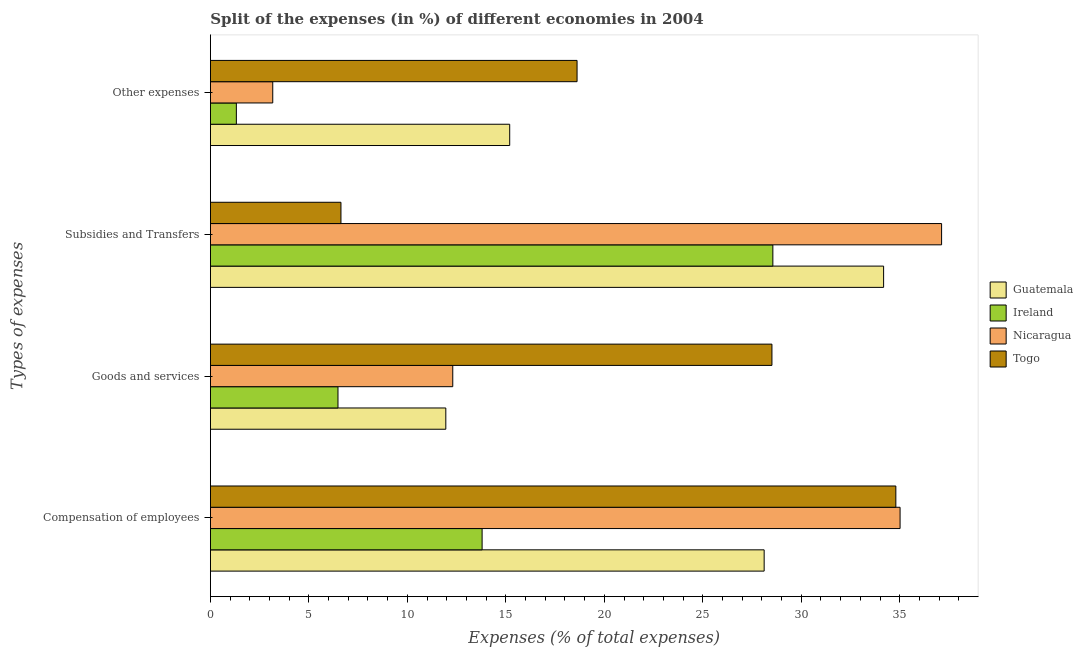How many groups of bars are there?
Provide a succinct answer. 4. How many bars are there on the 2nd tick from the top?
Offer a very short reply. 4. How many bars are there on the 2nd tick from the bottom?
Offer a very short reply. 4. What is the label of the 3rd group of bars from the top?
Offer a very short reply. Goods and services. What is the percentage of amount spent on compensation of employees in Ireland?
Give a very brief answer. 13.8. Across all countries, what is the maximum percentage of amount spent on goods and services?
Provide a short and direct response. 28.51. Across all countries, what is the minimum percentage of amount spent on compensation of employees?
Your response must be concise. 13.8. In which country was the percentage of amount spent on compensation of employees maximum?
Give a very brief answer. Nicaragua. In which country was the percentage of amount spent on goods and services minimum?
Ensure brevity in your answer.  Ireland. What is the total percentage of amount spent on subsidies in the graph?
Offer a very short reply. 106.49. What is the difference between the percentage of amount spent on compensation of employees in Togo and that in Nicaragua?
Your response must be concise. -0.22. What is the difference between the percentage of amount spent on compensation of employees in Nicaragua and the percentage of amount spent on other expenses in Ireland?
Keep it short and to the point. 33.7. What is the average percentage of amount spent on other expenses per country?
Your answer should be very brief. 9.57. What is the difference between the percentage of amount spent on goods and services and percentage of amount spent on other expenses in Guatemala?
Your answer should be very brief. -3.24. What is the ratio of the percentage of amount spent on compensation of employees in Nicaragua to that in Guatemala?
Give a very brief answer. 1.25. What is the difference between the highest and the second highest percentage of amount spent on other expenses?
Your answer should be very brief. 3.42. What is the difference between the highest and the lowest percentage of amount spent on other expenses?
Give a very brief answer. 17.3. In how many countries, is the percentage of amount spent on subsidies greater than the average percentage of amount spent on subsidies taken over all countries?
Provide a short and direct response. 3. Is the sum of the percentage of amount spent on goods and services in Guatemala and Nicaragua greater than the maximum percentage of amount spent on subsidies across all countries?
Ensure brevity in your answer.  No. What does the 2nd bar from the top in Compensation of employees represents?
Provide a short and direct response. Nicaragua. What does the 2nd bar from the bottom in Other expenses represents?
Offer a very short reply. Ireland. How many bars are there?
Your response must be concise. 16. How many countries are there in the graph?
Your answer should be compact. 4. What is the difference between two consecutive major ticks on the X-axis?
Offer a very short reply. 5. Are the values on the major ticks of X-axis written in scientific E-notation?
Offer a very short reply. No. Does the graph contain any zero values?
Provide a short and direct response. No. Does the graph contain grids?
Your response must be concise. No. How are the legend labels stacked?
Make the answer very short. Vertical. What is the title of the graph?
Your response must be concise. Split of the expenses (in %) of different economies in 2004. What is the label or title of the X-axis?
Make the answer very short. Expenses (% of total expenses). What is the label or title of the Y-axis?
Give a very brief answer. Types of expenses. What is the Expenses (% of total expenses) in Guatemala in Compensation of employees?
Keep it short and to the point. 28.12. What is the Expenses (% of total expenses) in Ireland in Compensation of employees?
Offer a terse response. 13.8. What is the Expenses (% of total expenses) in Nicaragua in Compensation of employees?
Your response must be concise. 35.02. What is the Expenses (% of total expenses) of Togo in Compensation of employees?
Keep it short and to the point. 34.8. What is the Expenses (% of total expenses) of Guatemala in Goods and services?
Your answer should be very brief. 11.95. What is the Expenses (% of total expenses) of Ireland in Goods and services?
Your answer should be compact. 6.48. What is the Expenses (% of total expenses) of Nicaragua in Goods and services?
Keep it short and to the point. 12.31. What is the Expenses (% of total expenses) of Togo in Goods and services?
Give a very brief answer. 28.51. What is the Expenses (% of total expenses) of Guatemala in Subsidies and Transfers?
Give a very brief answer. 34.18. What is the Expenses (% of total expenses) of Ireland in Subsidies and Transfers?
Your response must be concise. 28.56. What is the Expenses (% of total expenses) in Nicaragua in Subsidies and Transfers?
Ensure brevity in your answer.  37.12. What is the Expenses (% of total expenses) of Togo in Subsidies and Transfers?
Make the answer very short. 6.63. What is the Expenses (% of total expenses) of Guatemala in Other expenses?
Ensure brevity in your answer.  15.2. What is the Expenses (% of total expenses) in Ireland in Other expenses?
Provide a short and direct response. 1.32. What is the Expenses (% of total expenses) of Nicaragua in Other expenses?
Make the answer very short. 3.17. What is the Expenses (% of total expenses) in Togo in Other expenses?
Give a very brief answer. 18.62. Across all Types of expenses, what is the maximum Expenses (% of total expenses) of Guatemala?
Give a very brief answer. 34.18. Across all Types of expenses, what is the maximum Expenses (% of total expenses) in Ireland?
Your answer should be compact. 28.56. Across all Types of expenses, what is the maximum Expenses (% of total expenses) in Nicaragua?
Provide a succinct answer. 37.12. Across all Types of expenses, what is the maximum Expenses (% of total expenses) of Togo?
Give a very brief answer. 34.8. Across all Types of expenses, what is the minimum Expenses (% of total expenses) in Guatemala?
Make the answer very short. 11.95. Across all Types of expenses, what is the minimum Expenses (% of total expenses) of Ireland?
Offer a terse response. 1.32. Across all Types of expenses, what is the minimum Expenses (% of total expenses) of Nicaragua?
Provide a short and direct response. 3.17. Across all Types of expenses, what is the minimum Expenses (% of total expenses) in Togo?
Your answer should be compact. 6.63. What is the total Expenses (% of total expenses) in Guatemala in the graph?
Your answer should be compact. 89.44. What is the total Expenses (% of total expenses) in Ireland in the graph?
Offer a terse response. 50.15. What is the total Expenses (% of total expenses) in Nicaragua in the graph?
Offer a very short reply. 87.61. What is the total Expenses (% of total expenses) of Togo in the graph?
Ensure brevity in your answer.  88.56. What is the difference between the Expenses (% of total expenses) of Guatemala in Compensation of employees and that in Goods and services?
Your answer should be very brief. 16.16. What is the difference between the Expenses (% of total expenses) in Ireland in Compensation of employees and that in Goods and services?
Your answer should be very brief. 7.32. What is the difference between the Expenses (% of total expenses) of Nicaragua in Compensation of employees and that in Goods and services?
Keep it short and to the point. 22.71. What is the difference between the Expenses (% of total expenses) of Togo in Compensation of employees and that in Goods and services?
Your answer should be compact. 6.29. What is the difference between the Expenses (% of total expenses) of Guatemala in Compensation of employees and that in Subsidies and Transfers?
Give a very brief answer. -6.06. What is the difference between the Expenses (% of total expenses) in Ireland in Compensation of employees and that in Subsidies and Transfers?
Ensure brevity in your answer.  -14.76. What is the difference between the Expenses (% of total expenses) in Nicaragua in Compensation of employees and that in Subsidies and Transfers?
Keep it short and to the point. -2.11. What is the difference between the Expenses (% of total expenses) in Togo in Compensation of employees and that in Subsidies and Transfers?
Your answer should be compact. 28.17. What is the difference between the Expenses (% of total expenses) in Guatemala in Compensation of employees and that in Other expenses?
Keep it short and to the point. 12.92. What is the difference between the Expenses (% of total expenses) of Ireland in Compensation of employees and that in Other expenses?
Your answer should be very brief. 12.48. What is the difference between the Expenses (% of total expenses) in Nicaragua in Compensation of employees and that in Other expenses?
Ensure brevity in your answer.  31.85. What is the difference between the Expenses (% of total expenses) in Togo in Compensation of employees and that in Other expenses?
Your answer should be compact. 16.18. What is the difference between the Expenses (% of total expenses) of Guatemala in Goods and services and that in Subsidies and Transfers?
Provide a succinct answer. -22.23. What is the difference between the Expenses (% of total expenses) of Ireland in Goods and services and that in Subsidies and Transfers?
Make the answer very short. -22.08. What is the difference between the Expenses (% of total expenses) of Nicaragua in Goods and services and that in Subsidies and Transfers?
Provide a short and direct response. -24.82. What is the difference between the Expenses (% of total expenses) of Togo in Goods and services and that in Subsidies and Transfers?
Offer a terse response. 21.88. What is the difference between the Expenses (% of total expenses) of Guatemala in Goods and services and that in Other expenses?
Ensure brevity in your answer.  -3.24. What is the difference between the Expenses (% of total expenses) in Ireland in Goods and services and that in Other expenses?
Your response must be concise. 5.16. What is the difference between the Expenses (% of total expenses) of Nicaragua in Goods and services and that in Other expenses?
Offer a very short reply. 9.14. What is the difference between the Expenses (% of total expenses) of Togo in Goods and services and that in Other expenses?
Offer a very short reply. 9.89. What is the difference between the Expenses (% of total expenses) in Guatemala in Subsidies and Transfers and that in Other expenses?
Your response must be concise. 18.98. What is the difference between the Expenses (% of total expenses) of Ireland in Subsidies and Transfers and that in Other expenses?
Make the answer very short. 27.24. What is the difference between the Expenses (% of total expenses) of Nicaragua in Subsidies and Transfers and that in Other expenses?
Keep it short and to the point. 33.96. What is the difference between the Expenses (% of total expenses) in Togo in Subsidies and Transfers and that in Other expenses?
Ensure brevity in your answer.  -11.99. What is the difference between the Expenses (% of total expenses) in Guatemala in Compensation of employees and the Expenses (% of total expenses) in Ireland in Goods and services?
Your answer should be compact. 21.64. What is the difference between the Expenses (% of total expenses) in Guatemala in Compensation of employees and the Expenses (% of total expenses) in Nicaragua in Goods and services?
Ensure brevity in your answer.  15.81. What is the difference between the Expenses (% of total expenses) of Guatemala in Compensation of employees and the Expenses (% of total expenses) of Togo in Goods and services?
Provide a short and direct response. -0.4. What is the difference between the Expenses (% of total expenses) in Ireland in Compensation of employees and the Expenses (% of total expenses) in Nicaragua in Goods and services?
Make the answer very short. 1.49. What is the difference between the Expenses (% of total expenses) of Ireland in Compensation of employees and the Expenses (% of total expenses) of Togo in Goods and services?
Your answer should be compact. -14.72. What is the difference between the Expenses (% of total expenses) of Nicaragua in Compensation of employees and the Expenses (% of total expenses) of Togo in Goods and services?
Give a very brief answer. 6.51. What is the difference between the Expenses (% of total expenses) of Guatemala in Compensation of employees and the Expenses (% of total expenses) of Ireland in Subsidies and Transfers?
Your answer should be compact. -0.44. What is the difference between the Expenses (% of total expenses) in Guatemala in Compensation of employees and the Expenses (% of total expenses) in Nicaragua in Subsidies and Transfers?
Ensure brevity in your answer.  -9.01. What is the difference between the Expenses (% of total expenses) of Guatemala in Compensation of employees and the Expenses (% of total expenses) of Togo in Subsidies and Transfers?
Make the answer very short. 21.49. What is the difference between the Expenses (% of total expenses) of Ireland in Compensation of employees and the Expenses (% of total expenses) of Nicaragua in Subsidies and Transfers?
Your response must be concise. -23.33. What is the difference between the Expenses (% of total expenses) of Ireland in Compensation of employees and the Expenses (% of total expenses) of Togo in Subsidies and Transfers?
Your response must be concise. 7.17. What is the difference between the Expenses (% of total expenses) of Nicaragua in Compensation of employees and the Expenses (% of total expenses) of Togo in Subsidies and Transfers?
Give a very brief answer. 28.39. What is the difference between the Expenses (% of total expenses) of Guatemala in Compensation of employees and the Expenses (% of total expenses) of Ireland in Other expenses?
Provide a short and direct response. 26.8. What is the difference between the Expenses (% of total expenses) of Guatemala in Compensation of employees and the Expenses (% of total expenses) of Nicaragua in Other expenses?
Ensure brevity in your answer.  24.95. What is the difference between the Expenses (% of total expenses) in Guatemala in Compensation of employees and the Expenses (% of total expenses) in Togo in Other expenses?
Your response must be concise. 9.5. What is the difference between the Expenses (% of total expenses) in Ireland in Compensation of employees and the Expenses (% of total expenses) in Nicaragua in Other expenses?
Offer a very short reply. 10.63. What is the difference between the Expenses (% of total expenses) in Ireland in Compensation of employees and the Expenses (% of total expenses) in Togo in Other expenses?
Offer a very short reply. -4.82. What is the difference between the Expenses (% of total expenses) in Nicaragua in Compensation of employees and the Expenses (% of total expenses) in Togo in Other expenses?
Give a very brief answer. 16.4. What is the difference between the Expenses (% of total expenses) in Guatemala in Goods and services and the Expenses (% of total expenses) in Ireland in Subsidies and Transfers?
Provide a short and direct response. -16.6. What is the difference between the Expenses (% of total expenses) of Guatemala in Goods and services and the Expenses (% of total expenses) of Nicaragua in Subsidies and Transfers?
Make the answer very short. -25.17. What is the difference between the Expenses (% of total expenses) of Guatemala in Goods and services and the Expenses (% of total expenses) of Togo in Subsidies and Transfers?
Give a very brief answer. 5.32. What is the difference between the Expenses (% of total expenses) of Ireland in Goods and services and the Expenses (% of total expenses) of Nicaragua in Subsidies and Transfers?
Provide a short and direct response. -30.65. What is the difference between the Expenses (% of total expenses) in Ireland in Goods and services and the Expenses (% of total expenses) in Togo in Subsidies and Transfers?
Provide a short and direct response. -0.15. What is the difference between the Expenses (% of total expenses) in Nicaragua in Goods and services and the Expenses (% of total expenses) in Togo in Subsidies and Transfers?
Your response must be concise. 5.68. What is the difference between the Expenses (% of total expenses) in Guatemala in Goods and services and the Expenses (% of total expenses) in Ireland in Other expenses?
Provide a succinct answer. 10.63. What is the difference between the Expenses (% of total expenses) in Guatemala in Goods and services and the Expenses (% of total expenses) in Nicaragua in Other expenses?
Your answer should be compact. 8.79. What is the difference between the Expenses (% of total expenses) of Guatemala in Goods and services and the Expenses (% of total expenses) of Togo in Other expenses?
Your response must be concise. -6.66. What is the difference between the Expenses (% of total expenses) of Ireland in Goods and services and the Expenses (% of total expenses) of Nicaragua in Other expenses?
Give a very brief answer. 3.31. What is the difference between the Expenses (% of total expenses) of Ireland in Goods and services and the Expenses (% of total expenses) of Togo in Other expenses?
Ensure brevity in your answer.  -12.14. What is the difference between the Expenses (% of total expenses) of Nicaragua in Goods and services and the Expenses (% of total expenses) of Togo in Other expenses?
Offer a very short reply. -6.31. What is the difference between the Expenses (% of total expenses) of Guatemala in Subsidies and Transfers and the Expenses (% of total expenses) of Ireland in Other expenses?
Provide a short and direct response. 32.86. What is the difference between the Expenses (% of total expenses) in Guatemala in Subsidies and Transfers and the Expenses (% of total expenses) in Nicaragua in Other expenses?
Offer a terse response. 31.01. What is the difference between the Expenses (% of total expenses) in Guatemala in Subsidies and Transfers and the Expenses (% of total expenses) in Togo in Other expenses?
Your answer should be compact. 15.56. What is the difference between the Expenses (% of total expenses) of Ireland in Subsidies and Transfers and the Expenses (% of total expenses) of Nicaragua in Other expenses?
Provide a succinct answer. 25.39. What is the difference between the Expenses (% of total expenses) in Ireland in Subsidies and Transfers and the Expenses (% of total expenses) in Togo in Other expenses?
Make the answer very short. 9.94. What is the difference between the Expenses (% of total expenses) in Nicaragua in Subsidies and Transfers and the Expenses (% of total expenses) in Togo in Other expenses?
Your answer should be compact. 18.51. What is the average Expenses (% of total expenses) in Guatemala per Types of expenses?
Provide a succinct answer. 22.36. What is the average Expenses (% of total expenses) in Ireland per Types of expenses?
Give a very brief answer. 12.54. What is the average Expenses (% of total expenses) in Nicaragua per Types of expenses?
Provide a short and direct response. 21.9. What is the average Expenses (% of total expenses) of Togo per Types of expenses?
Your answer should be very brief. 22.14. What is the difference between the Expenses (% of total expenses) of Guatemala and Expenses (% of total expenses) of Ireland in Compensation of employees?
Give a very brief answer. 14.32. What is the difference between the Expenses (% of total expenses) in Guatemala and Expenses (% of total expenses) in Nicaragua in Compensation of employees?
Offer a terse response. -6.9. What is the difference between the Expenses (% of total expenses) in Guatemala and Expenses (% of total expenses) in Togo in Compensation of employees?
Make the answer very short. -6.69. What is the difference between the Expenses (% of total expenses) in Ireland and Expenses (% of total expenses) in Nicaragua in Compensation of employees?
Provide a short and direct response. -21.22. What is the difference between the Expenses (% of total expenses) of Ireland and Expenses (% of total expenses) of Togo in Compensation of employees?
Ensure brevity in your answer.  -21.01. What is the difference between the Expenses (% of total expenses) of Nicaragua and Expenses (% of total expenses) of Togo in Compensation of employees?
Provide a succinct answer. 0.22. What is the difference between the Expenses (% of total expenses) in Guatemala and Expenses (% of total expenses) in Ireland in Goods and services?
Make the answer very short. 5.47. What is the difference between the Expenses (% of total expenses) of Guatemala and Expenses (% of total expenses) of Nicaragua in Goods and services?
Your answer should be compact. -0.35. What is the difference between the Expenses (% of total expenses) of Guatemala and Expenses (% of total expenses) of Togo in Goods and services?
Ensure brevity in your answer.  -16.56. What is the difference between the Expenses (% of total expenses) in Ireland and Expenses (% of total expenses) in Nicaragua in Goods and services?
Offer a very short reply. -5.83. What is the difference between the Expenses (% of total expenses) in Ireland and Expenses (% of total expenses) in Togo in Goods and services?
Give a very brief answer. -22.03. What is the difference between the Expenses (% of total expenses) of Nicaragua and Expenses (% of total expenses) of Togo in Goods and services?
Offer a very short reply. -16.2. What is the difference between the Expenses (% of total expenses) in Guatemala and Expenses (% of total expenses) in Ireland in Subsidies and Transfers?
Offer a terse response. 5.62. What is the difference between the Expenses (% of total expenses) of Guatemala and Expenses (% of total expenses) of Nicaragua in Subsidies and Transfers?
Provide a short and direct response. -2.94. What is the difference between the Expenses (% of total expenses) in Guatemala and Expenses (% of total expenses) in Togo in Subsidies and Transfers?
Make the answer very short. 27.55. What is the difference between the Expenses (% of total expenses) in Ireland and Expenses (% of total expenses) in Nicaragua in Subsidies and Transfers?
Make the answer very short. -8.57. What is the difference between the Expenses (% of total expenses) in Ireland and Expenses (% of total expenses) in Togo in Subsidies and Transfers?
Make the answer very short. 21.93. What is the difference between the Expenses (% of total expenses) in Nicaragua and Expenses (% of total expenses) in Togo in Subsidies and Transfers?
Give a very brief answer. 30.49. What is the difference between the Expenses (% of total expenses) in Guatemala and Expenses (% of total expenses) in Ireland in Other expenses?
Ensure brevity in your answer.  13.88. What is the difference between the Expenses (% of total expenses) of Guatemala and Expenses (% of total expenses) of Nicaragua in Other expenses?
Provide a short and direct response. 12.03. What is the difference between the Expenses (% of total expenses) of Guatemala and Expenses (% of total expenses) of Togo in Other expenses?
Provide a short and direct response. -3.42. What is the difference between the Expenses (% of total expenses) of Ireland and Expenses (% of total expenses) of Nicaragua in Other expenses?
Provide a succinct answer. -1.85. What is the difference between the Expenses (% of total expenses) in Ireland and Expenses (% of total expenses) in Togo in Other expenses?
Offer a very short reply. -17.3. What is the difference between the Expenses (% of total expenses) in Nicaragua and Expenses (% of total expenses) in Togo in Other expenses?
Give a very brief answer. -15.45. What is the ratio of the Expenses (% of total expenses) in Guatemala in Compensation of employees to that in Goods and services?
Keep it short and to the point. 2.35. What is the ratio of the Expenses (% of total expenses) of Ireland in Compensation of employees to that in Goods and services?
Provide a short and direct response. 2.13. What is the ratio of the Expenses (% of total expenses) in Nicaragua in Compensation of employees to that in Goods and services?
Ensure brevity in your answer.  2.85. What is the ratio of the Expenses (% of total expenses) in Togo in Compensation of employees to that in Goods and services?
Make the answer very short. 1.22. What is the ratio of the Expenses (% of total expenses) of Guatemala in Compensation of employees to that in Subsidies and Transfers?
Provide a succinct answer. 0.82. What is the ratio of the Expenses (% of total expenses) in Ireland in Compensation of employees to that in Subsidies and Transfers?
Make the answer very short. 0.48. What is the ratio of the Expenses (% of total expenses) of Nicaragua in Compensation of employees to that in Subsidies and Transfers?
Make the answer very short. 0.94. What is the ratio of the Expenses (% of total expenses) of Togo in Compensation of employees to that in Subsidies and Transfers?
Offer a very short reply. 5.25. What is the ratio of the Expenses (% of total expenses) in Guatemala in Compensation of employees to that in Other expenses?
Your answer should be compact. 1.85. What is the ratio of the Expenses (% of total expenses) of Ireland in Compensation of employees to that in Other expenses?
Your response must be concise. 10.46. What is the ratio of the Expenses (% of total expenses) of Nicaragua in Compensation of employees to that in Other expenses?
Give a very brief answer. 11.06. What is the ratio of the Expenses (% of total expenses) in Togo in Compensation of employees to that in Other expenses?
Provide a succinct answer. 1.87. What is the ratio of the Expenses (% of total expenses) of Guatemala in Goods and services to that in Subsidies and Transfers?
Your answer should be very brief. 0.35. What is the ratio of the Expenses (% of total expenses) in Ireland in Goods and services to that in Subsidies and Transfers?
Your response must be concise. 0.23. What is the ratio of the Expenses (% of total expenses) of Nicaragua in Goods and services to that in Subsidies and Transfers?
Your answer should be very brief. 0.33. What is the ratio of the Expenses (% of total expenses) of Togo in Goods and services to that in Subsidies and Transfers?
Ensure brevity in your answer.  4.3. What is the ratio of the Expenses (% of total expenses) in Guatemala in Goods and services to that in Other expenses?
Ensure brevity in your answer.  0.79. What is the ratio of the Expenses (% of total expenses) of Ireland in Goods and services to that in Other expenses?
Make the answer very short. 4.91. What is the ratio of the Expenses (% of total expenses) of Nicaragua in Goods and services to that in Other expenses?
Make the answer very short. 3.89. What is the ratio of the Expenses (% of total expenses) in Togo in Goods and services to that in Other expenses?
Offer a terse response. 1.53. What is the ratio of the Expenses (% of total expenses) in Guatemala in Subsidies and Transfers to that in Other expenses?
Your response must be concise. 2.25. What is the ratio of the Expenses (% of total expenses) of Ireland in Subsidies and Transfers to that in Other expenses?
Your answer should be very brief. 21.66. What is the ratio of the Expenses (% of total expenses) of Nicaragua in Subsidies and Transfers to that in Other expenses?
Keep it short and to the point. 11.72. What is the ratio of the Expenses (% of total expenses) of Togo in Subsidies and Transfers to that in Other expenses?
Offer a terse response. 0.36. What is the difference between the highest and the second highest Expenses (% of total expenses) of Guatemala?
Provide a short and direct response. 6.06. What is the difference between the highest and the second highest Expenses (% of total expenses) of Ireland?
Make the answer very short. 14.76. What is the difference between the highest and the second highest Expenses (% of total expenses) in Nicaragua?
Your answer should be very brief. 2.11. What is the difference between the highest and the second highest Expenses (% of total expenses) of Togo?
Ensure brevity in your answer.  6.29. What is the difference between the highest and the lowest Expenses (% of total expenses) of Guatemala?
Make the answer very short. 22.23. What is the difference between the highest and the lowest Expenses (% of total expenses) of Ireland?
Make the answer very short. 27.24. What is the difference between the highest and the lowest Expenses (% of total expenses) in Nicaragua?
Your answer should be compact. 33.96. What is the difference between the highest and the lowest Expenses (% of total expenses) in Togo?
Provide a short and direct response. 28.17. 